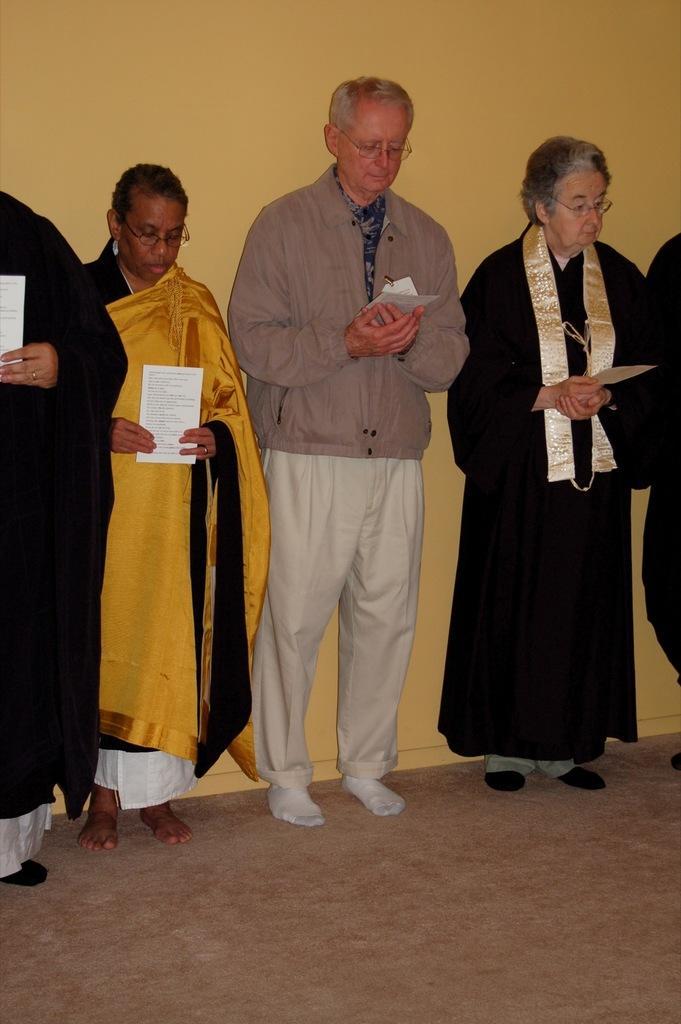Could you give a brief overview of what you see in this image? In the middle of the image few people are standing and holding some papers. Behind them there is a wall. 